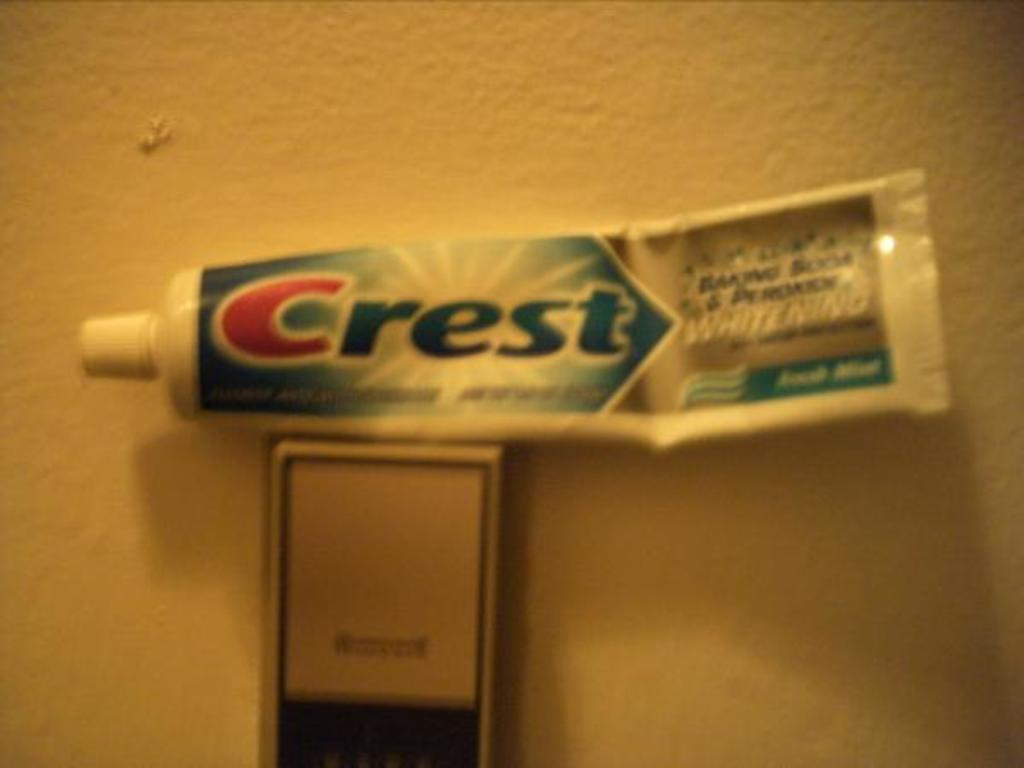<image>
Share a concise interpretation of the image provided. A tube of Crest fresh mint toothpaste is on top of a thermostat. 